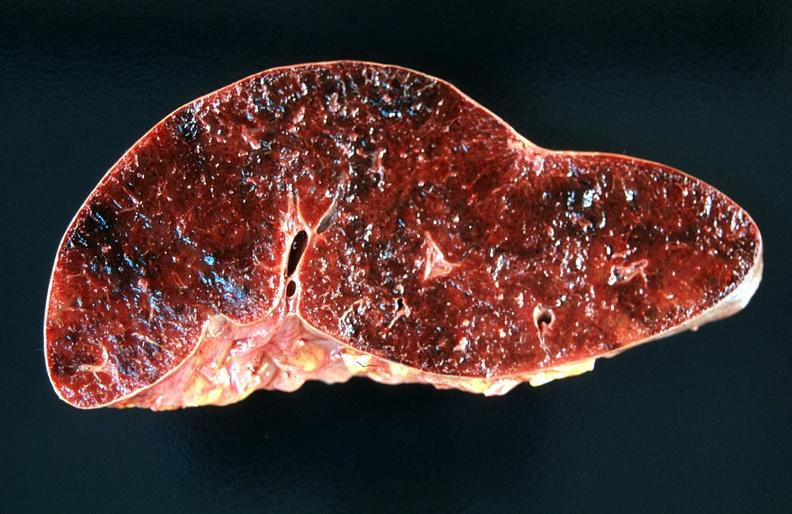does this image show spleen, chronic congestion and hemorrhage?
Answer the question using a single word or phrase. Yes 